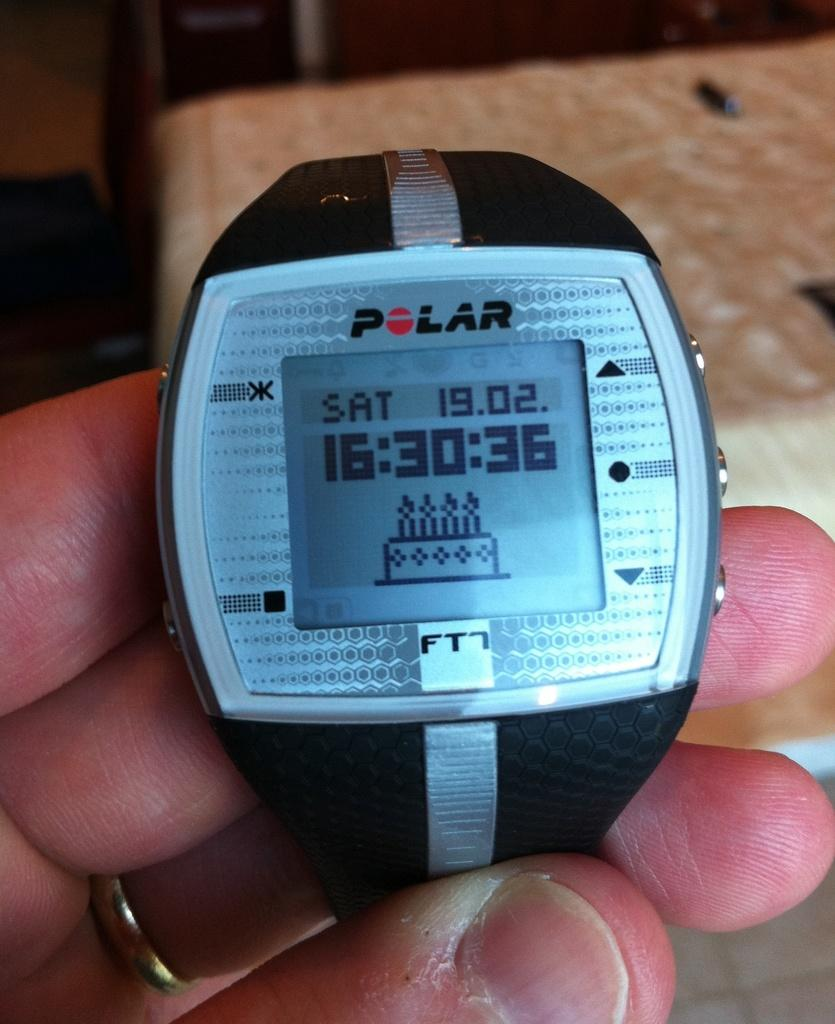<image>
Relay a brief, clear account of the picture shown. A Polar FT watch that have the time and day 